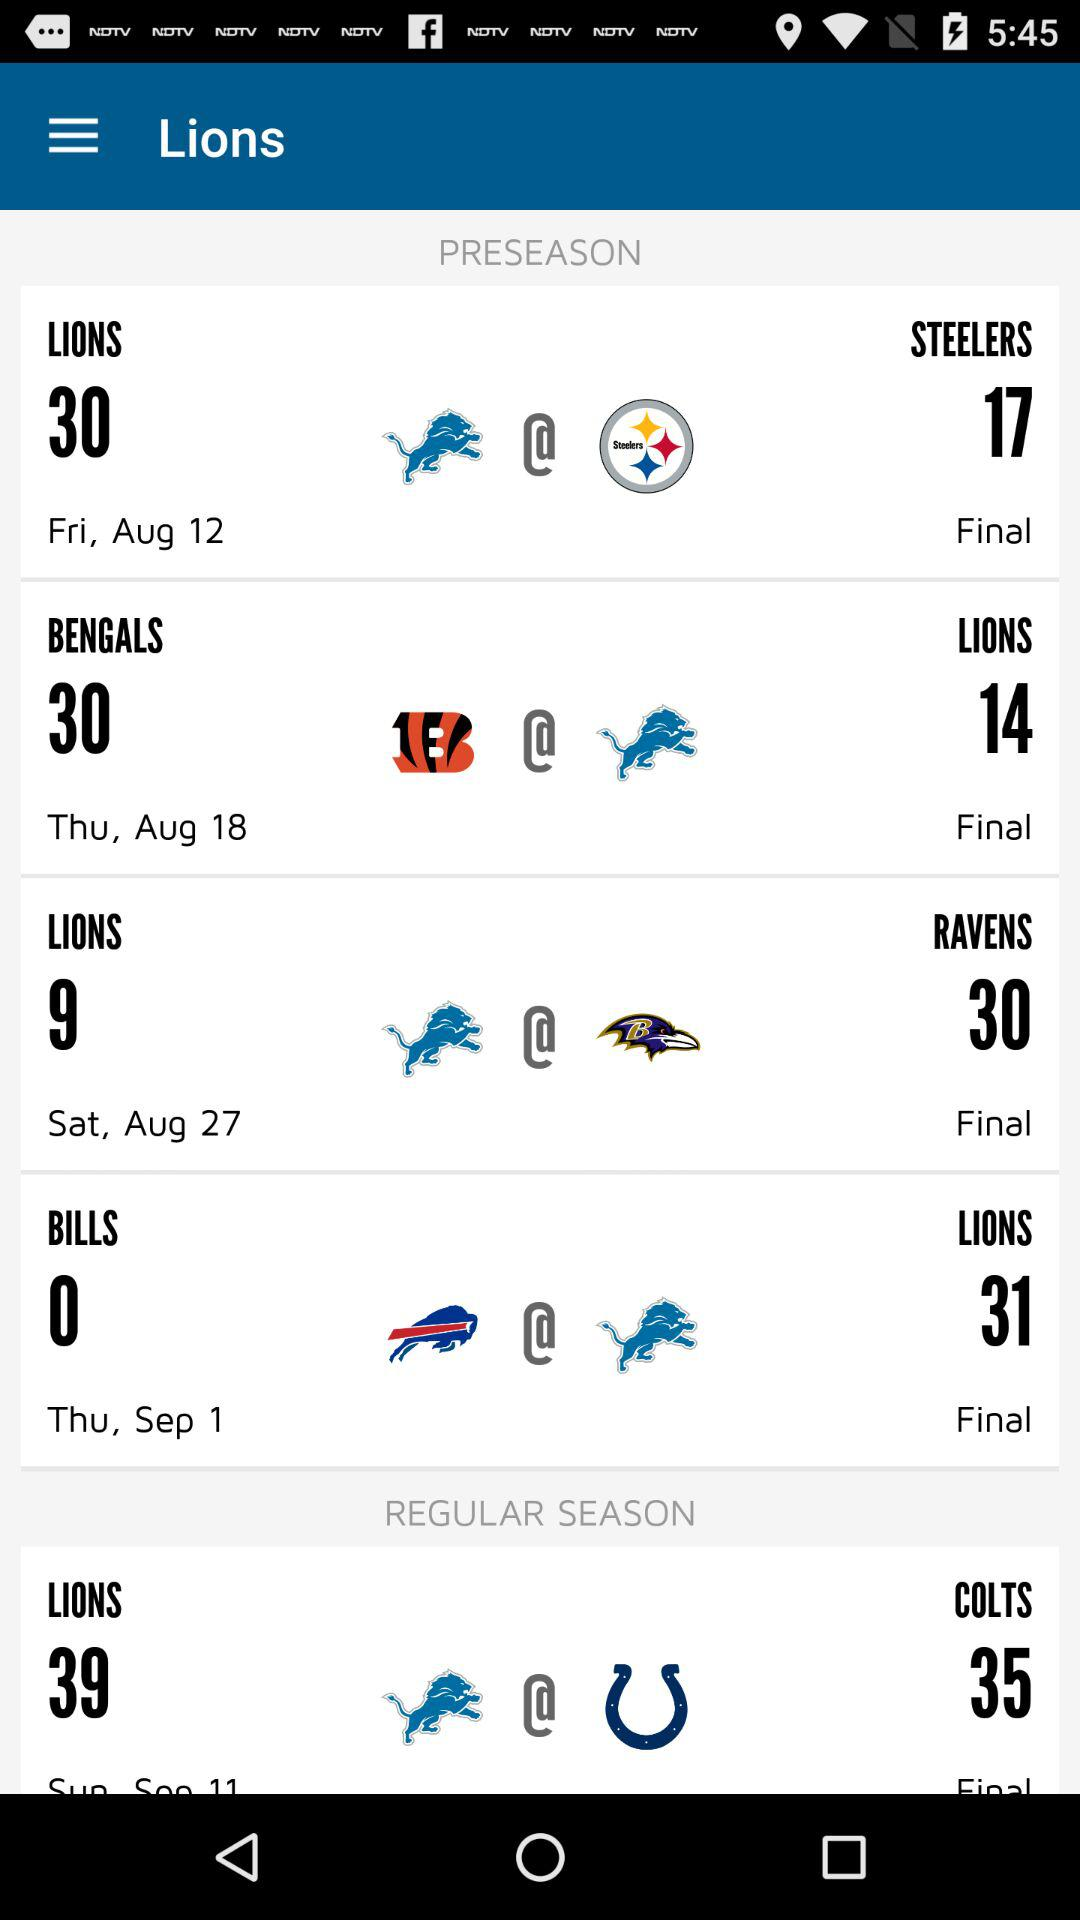What is the date of the match between "BENGALS" and "LIONS" in "PRESEASON"? The date is Thursday, August 18. 